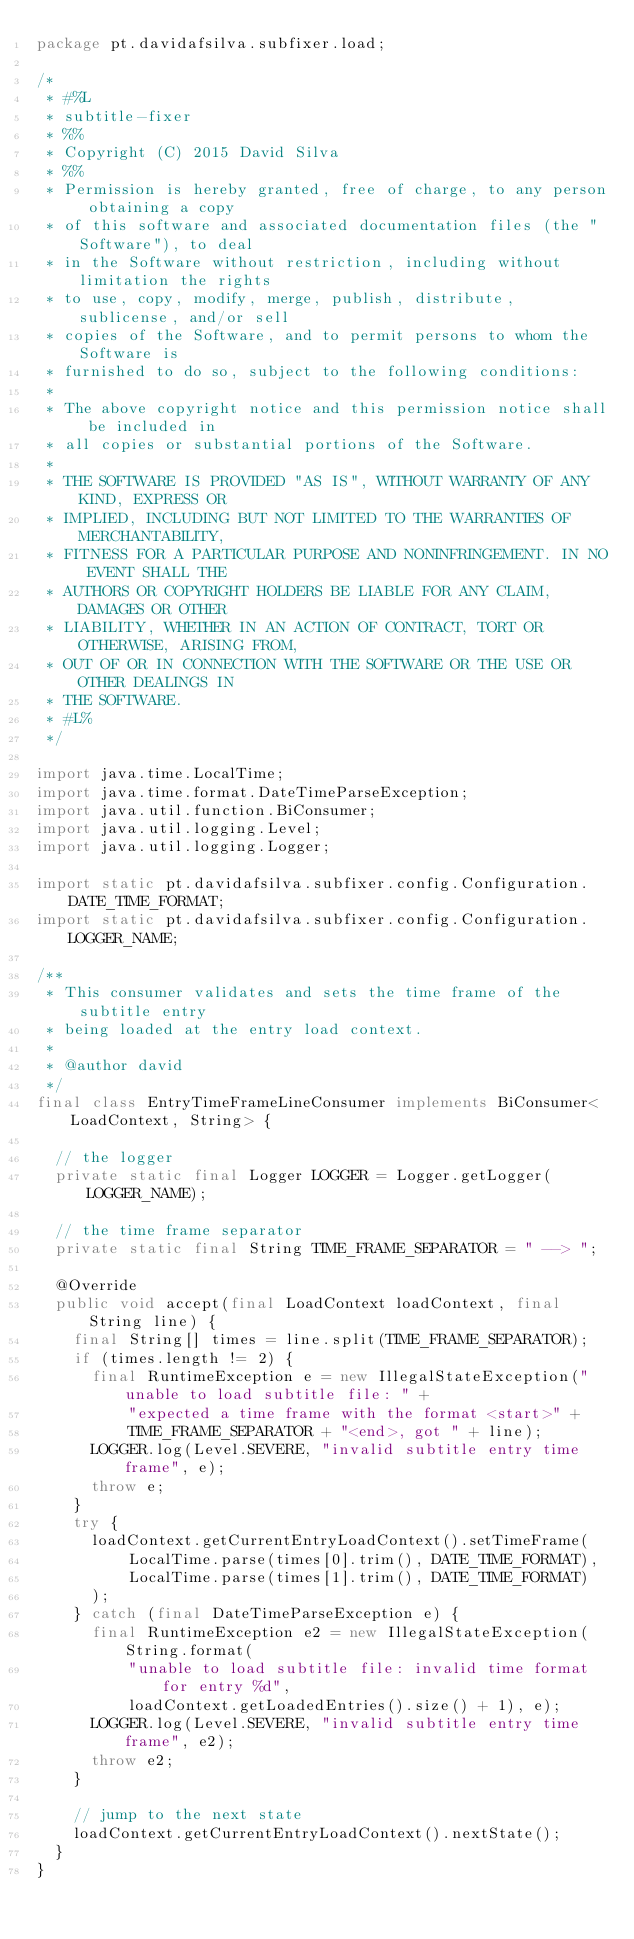Convert code to text. <code><loc_0><loc_0><loc_500><loc_500><_Java_>package pt.davidafsilva.subfixer.load;

/*
 * #%L
 * subtitle-fixer
 * %%
 * Copyright (C) 2015 David Silva
 * %%
 * Permission is hereby granted, free of charge, to any person obtaining a copy
 * of this software and associated documentation files (the "Software"), to deal
 * in the Software without restriction, including without limitation the rights
 * to use, copy, modify, merge, publish, distribute, sublicense, and/or sell
 * copies of the Software, and to permit persons to whom the Software is
 * furnished to do so, subject to the following conditions:
 * 
 * The above copyright notice and this permission notice shall be included in
 * all copies or substantial portions of the Software.
 * 
 * THE SOFTWARE IS PROVIDED "AS IS", WITHOUT WARRANTY OF ANY KIND, EXPRESS OR
 * IMPLIED, INCLUDING BUT NOT LIMITED TO THE WARRANTIES OF MERCHANTABILITY,
 * FITNESS FOR A PARTICULAR PURPOSE AND NONINFRINGEMENT. IN NO EVENT SHALL THE
 * AUTHORS OR COPYRIGHT HOLDERS BE LIABLE FOR ANY CLAIM, DAMAGES OR OTHER
 * LIABILITY, WHETHER IN AN ACTION OF CONTRACT, TORT OR OTHERWISE, ARISING FROM,
 * OUT OF OR IN CONNECTION WITH THE SOFTWARE OR THE USE OR OTHER DEALINGS IN
 * THE SOFTWARE.
 * #L%
 */

import java.time.LocalTime;
import java.time.format.DateTimeParseException;
import java.util.function.BiConsumer;
import java.util.logging.Level;
import java.util.logging.Logger;

import static pt.davidafsilva.subfixer.config.Configuration.DATE_TIME_FORMAT;
import static pt.davidafsilva.subfixer.config.Configuration.LOGGER_NAME;

/**
 * This consumer validates and sets the time frame of the subtitle entry
 * being loaded at the entry load context.
 *
 * @author david
 */
final class EntryTimeFrameLineConsumer implements BiConsumer<LoadContext, String> {

  // the logger
  private static final Logger LOGGER = Logger.getLogger(LOGGER_NAME);

  // the time frame separator
  private static final String TIME_FRAME_SEPARATOR = " --> ";

  @Override
  public void accept(final LoadContext loadContext, final String line) {
    final String[] times = line.split(TIME_FRAME_SEPARATOR);
    if (times.length != 2) {
      final RuntimeException e = new IllegalStateException("unable to load subtitle file: " +
          "expected a time frame with the format <start>" +
          TIME_FRAME_SEPARATOR + "<end>, got " + line);
      LOGGER.log(Level.SEVERE, "invalid subtitle entry time frame", e);
      throw e;
    }
    try {
      loadContext.getCurrentEntryLoadContext().setTimeFrame(
          LocalTime.parse(times[0].trim(), DATE_TIME_FORMAT),
          LocalTime.parse(times[1].trim(), DATE_TIME_FORMAT)
      );
    } catch (final DateTimeParseException e) {
      final RuntimeException e2 = new IllegalStateException(String.format(
          "unable to load subtitle file: invalid time format for entry %d",
          loadContext.getLoadedEntries().size() + 1), e);
      LOGGER.log(Level.SEVERE, "invalid subtitle entry time frame", e2);
      throw e2;
    }

    // jump to the next state
    loadContext.getCurrentEntryLoadContext().nextState();
  }
}
</code> 